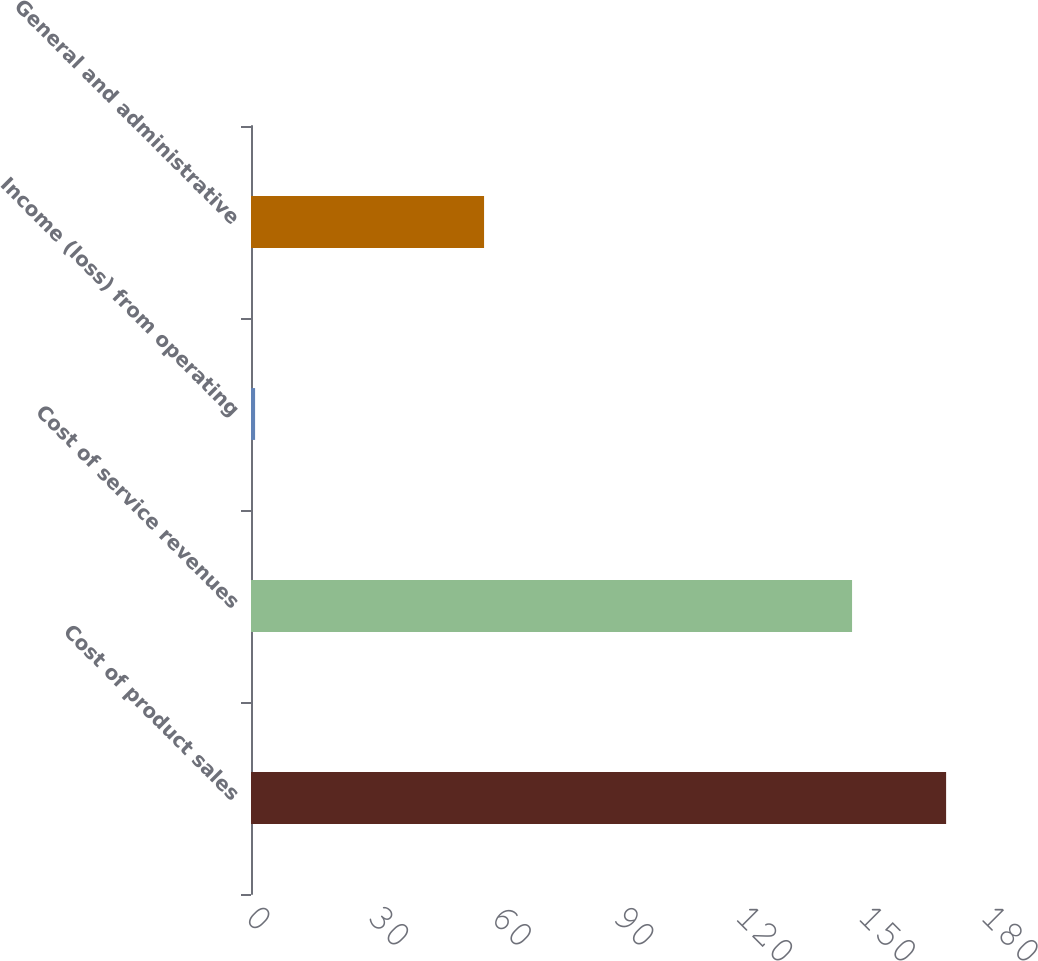Convert chart to OTSL. <chart><loc_0><loc_0><loc_500><loc_500><bar_chart><fcel>Cost of product sales<fcel>Cost of service revenues<fcel>Income (loss) from operating<fcel>General and administrative<nl><fcel>170<fcel>147<fcel>1<fcel>57<nl></chart> 